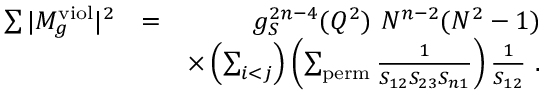<formula> <loc_0><loc_0><loc_500><loc_500>\begin{array} { r l r } { \sum | M _ { g } ^ { v i o l } | ^ { 2 } } & { = } & { g _ { S } ^ { 2 n - 4 } ( Q ^ { 2 } ) N ^ { n - 2 } ( N ^ { 2 } - 1 ) } \\ & { \times \left ( \sum _ { i < j } \right ) \left ( \sum _ { p e r m } \frac { 1 } { S _ { 1 2 } S _ { 2 3 } S _ { n 1 } } \right ) \frac { 1 } { S _ { 1 2 } } . } \end{array}</formula> 